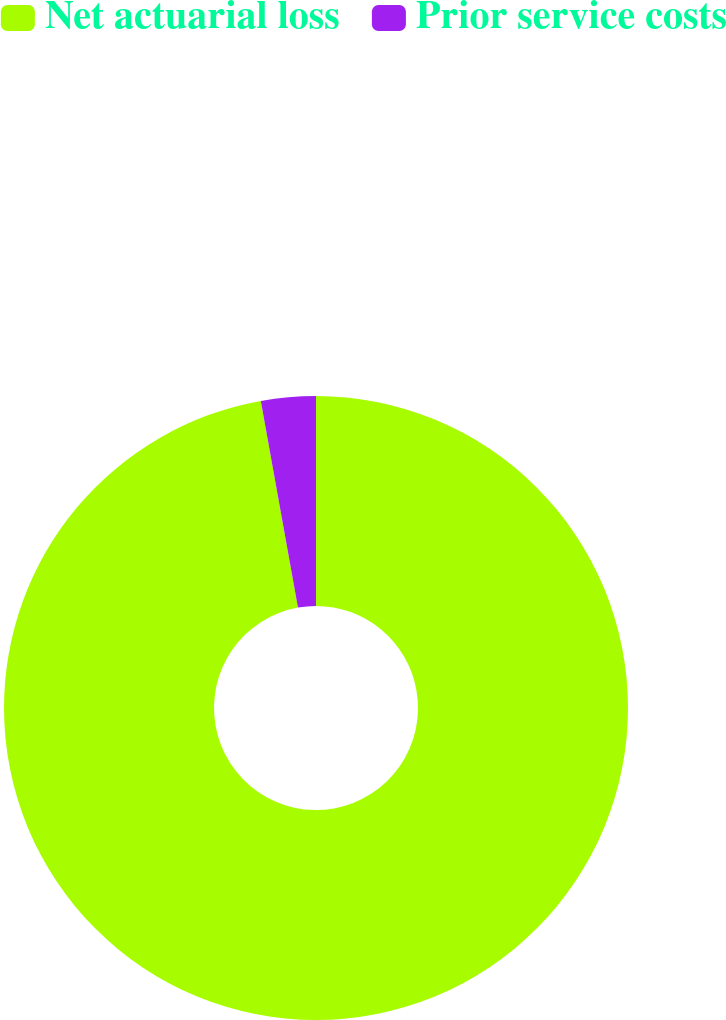<chart> <loc_0><loc_0><loc_500><loc_500><pie_chart><fcel>Net actuarial loss<fcel>Prior service costs<nl><fcel>97.17%<fcel>2.83%<nl></chart> 